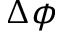<formula> <loc_0><loc_0><loc_500><loc_500>\Delta \phi</formula> 